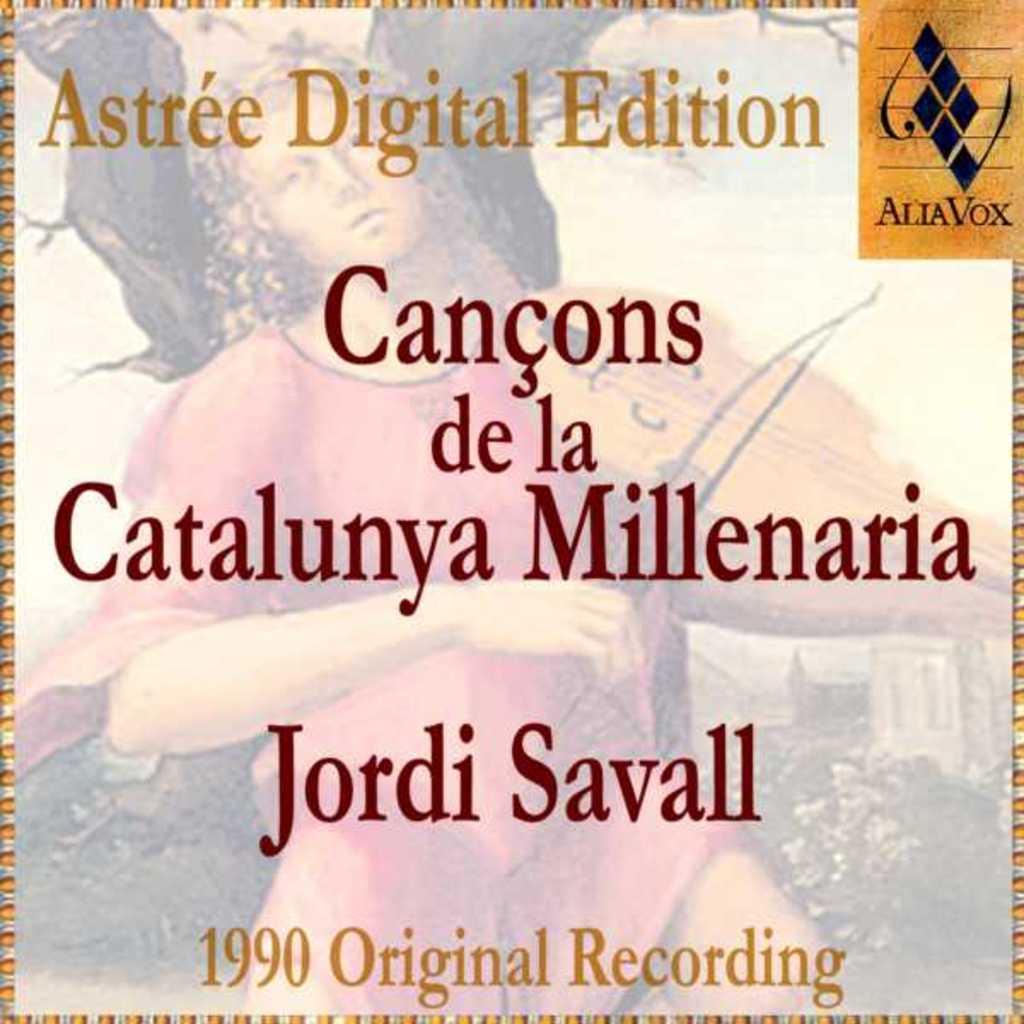When was the album orignally recorded?
Provide a succinct answer. 1990. 